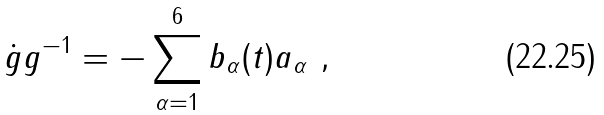<formula> <loc_0><loc_0><loc_500><loc_500>\dot { g } g ^ { - 1 } = - \sum _ { \alpha = 1 } ^ { 6 } b _ { \alpha } ( t ) a _ { \alpha } \ ,</formula> 